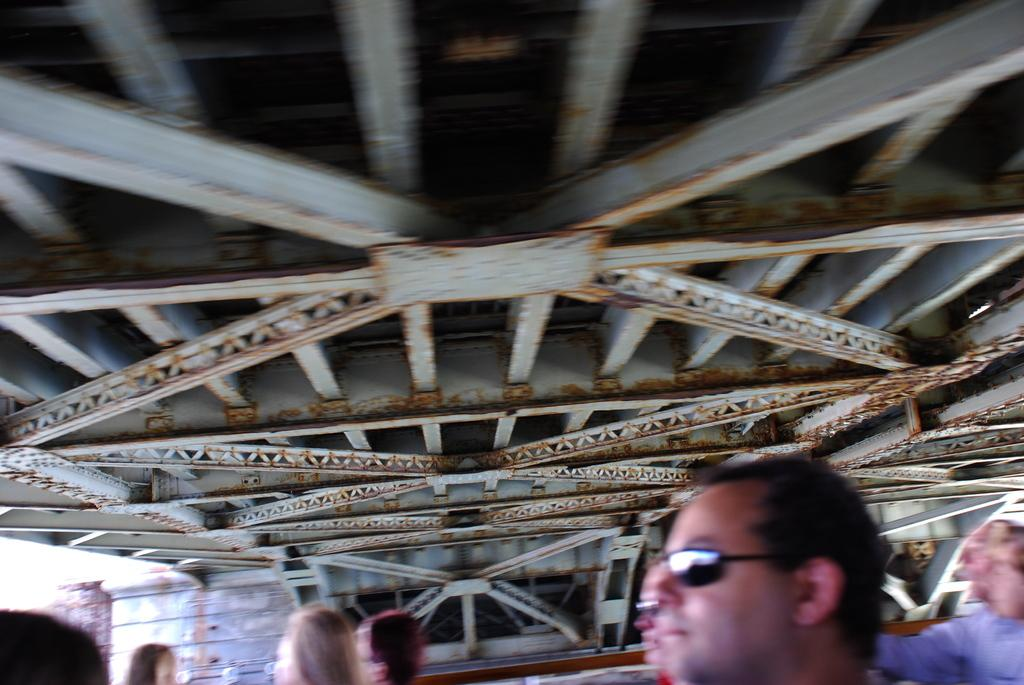How many people are in the image? There is a group of people in the image. What objects can be seen in the image besides the people? Metal rods are present in the image. What type of structure is visible in the image? There is a wall and a door in the image. Can you describe the lighting conditions in the image? The image was likely taken during the day, as there is sufficient natural light. What type of snake can be seen slithering on the wall in the image? There is no snake present in the image; it only features a group of people, metal rods, a wall, and a door. 